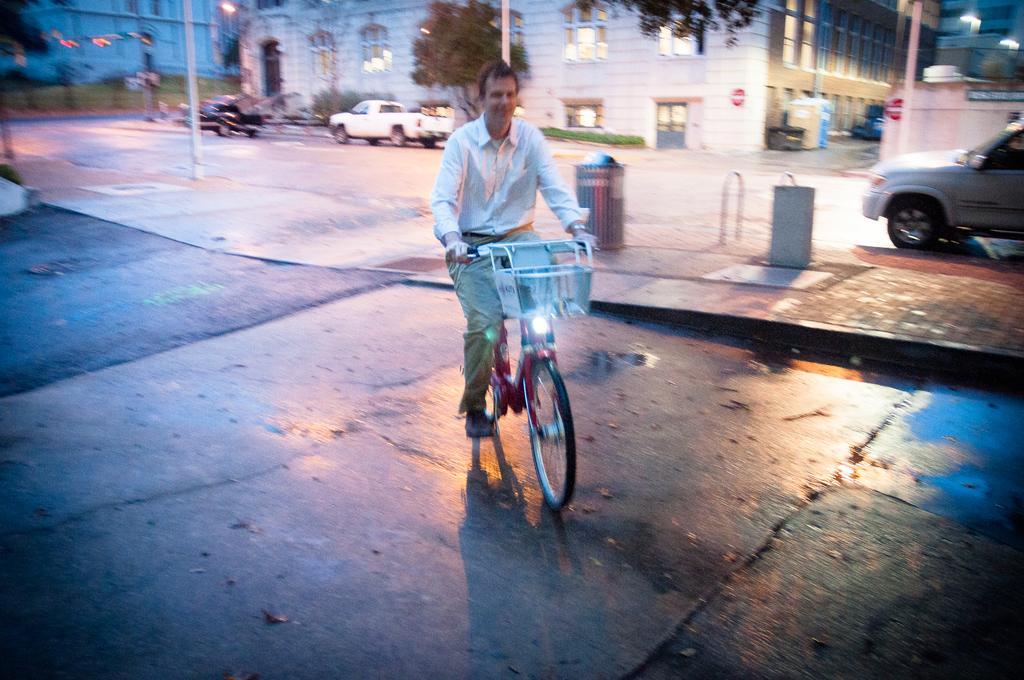Can you describe this image briefly? This is the picture on the road. There is a person riding bicycle on the road. At the right side there is a car, at the back there are two cars and trees and there is a buildings and there are poles on the footpath. 